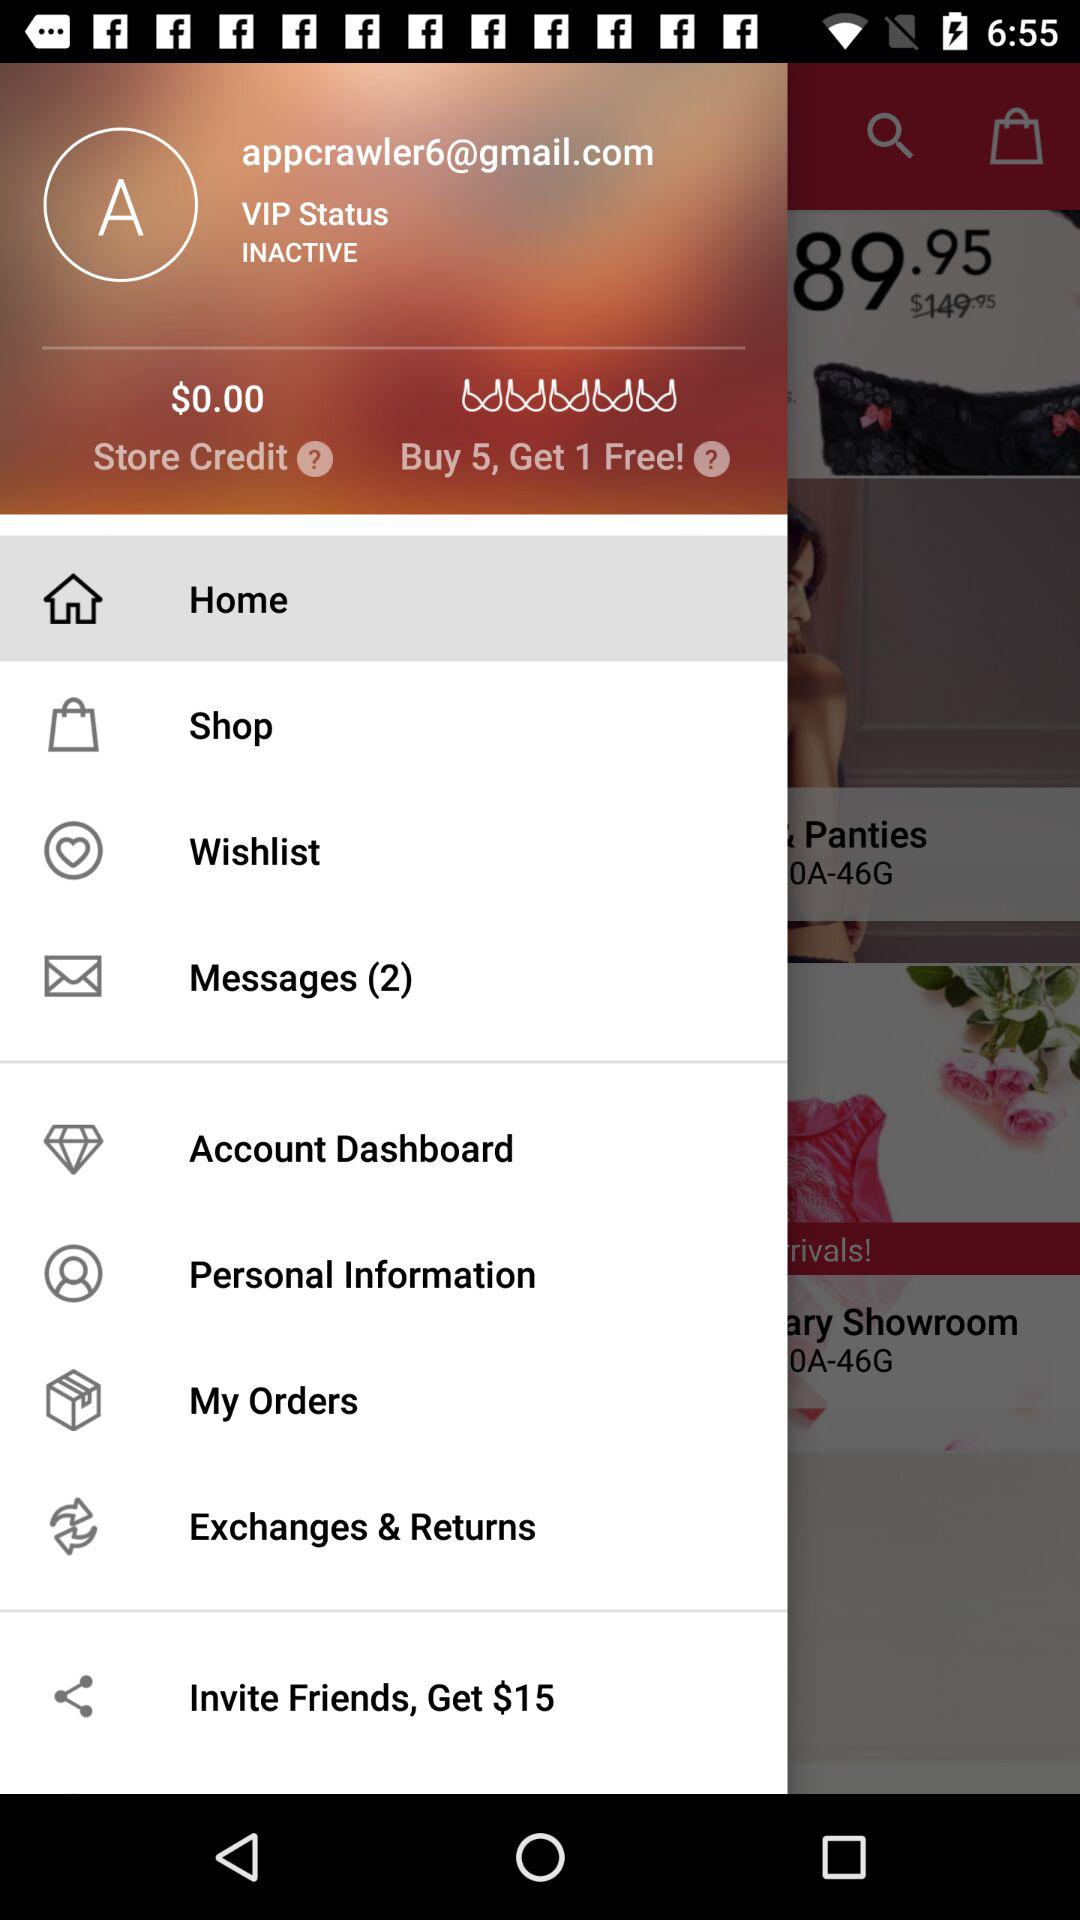What is the amount of store credit? The amount is $0.00. 